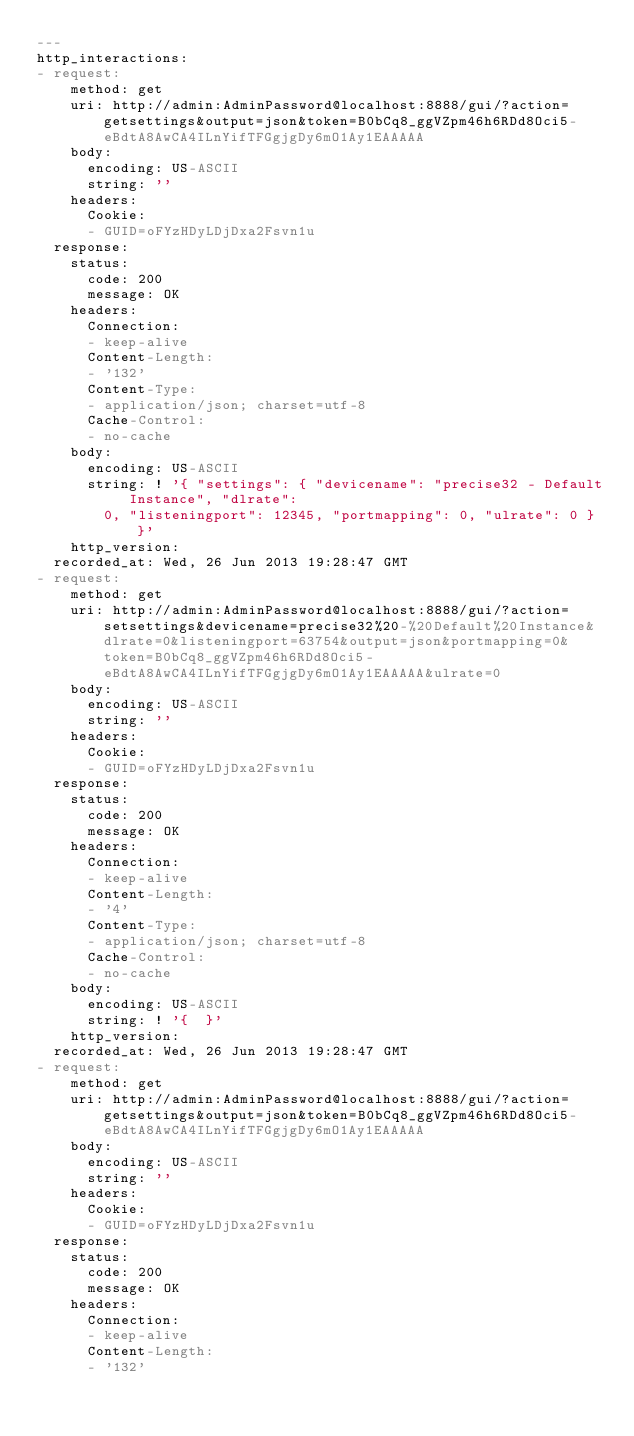<code> <loc_0><loc_0><loc_500><loc_500><_YAML_>---
http_interactions:
- request:
    method: get
    uri: http://admin:AdminPassword@localhost:8888/gui/?action=getsettings&output=json&token=B0bCq8_ggVZpm46h6RDd8Oci5-eBdtA8AwCA4ILnYifTFGgjgDy6mO1Ay1EAAAAA
    body:
      encoding: US-ASCII
      string: ''
    headers:
      Cookie:
      - GUID=oFYzHDyLDjDxa2Fsvn1u
  response:
    status:
      code: 200
      message: OK
    headers:
      Connection:
      - keep-alive
      Content-Length:
      - '132'
      Content-Type:
      - application/json; charset=utf-8
      Cache-Control:
      - no-cache
    body:
      encoding: US-ASCII
      string: ! '{ "settings": { "devicename": "precise32 - Default Instance", "dlrate":
        0, "listeningport": 12345, "portmapping": 0, "ulrate": 0 } }'
    http_version: 
  recorded_at: Wed, 26 Jun 2013 19:28:47 GMT
- request:
    method: get
    uri: http://admin:AdminPassword@localhost:8888/gui/?action=setsettings&devicename=precise32%20-%20Default%20Instance&dlrate=0&listeningport=63754&output=json&portmapping=0&token=B0bCq8_ggVZpm46h6RDd8Oci5-eBdtA8AwCA4ILnYifTFGgjgDy6mO1Ay1EAAAAA&ulrate=0
    body:
      encoding: US-ASCII
      string: ''
    headers:
      Cookie:
      - GUID=oFYzHDyLDjDxa2Fsvn1u
  response:
    status:
      code: 200
      message: OK
    headers:
      Connection:
      - keep-alive
      Content-Length:
      - '4'
      Content-Type:
      - application/json; charset=utf-8
      Cache-Control:
      - no-cache
    body:
      encoding: US-ASCII
      string: ! '{  }'
    http_version: 
  recorded_at: Wed, 26 Jun 2013 19:28:47 GMT
- request:
    method: get
    uri: http://admin:AdminPassword@localhost:8888/gui/?action=getsettings&output=json&token=B0bCq8_ggVZpm46h6RDd8Oci5-eBdtA8AwCA4ILnYifTFGgjgDy6mO1Ay1EAAAAA
    body:
      encoding: US-ASCII
      string: ''
    headers:
      Cookie:
      - GUID=oFYzHDyLDjDxa2Fsvn1u
  response:
    status:
      code: 200
      message: OK
    headers:
      Connection:
      - keep-alive
      Content-Length:
      - '132'</code> 